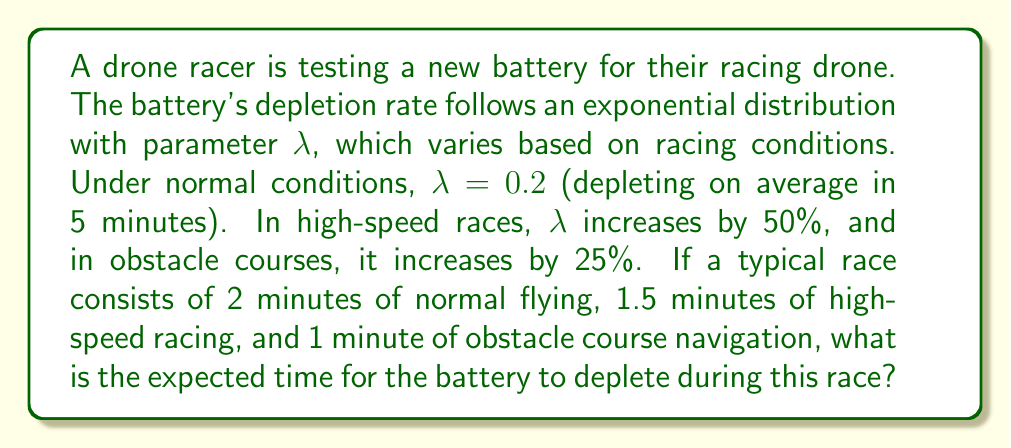Could you help me with this problem? Let's approach this step-by-step:

1) First, recall that for an exponential distribution with parameter $\lambda$, the expected value (mean time) is $\frac{1}{\lambda}$.

2) We have three different racing conditions:
   - Normal: $\lambda_1 = 0.2$
   - High-speed: $\lambda_2 = 0.2 \times 1.5 = 0.3$
   - Obstacle course: $\lambda_3 = 0.2 \times 1.25 = 0.25$

3) The race consists of different segments. We need to calculate the probability of the battery lasting through each segment and then multiply these probabilities.

4) For an exponential distribution, the probability of lasting time $t$ is $e^{-\lambda t}$. So for each segment:
   - Normal (2 min): $P_1 = e^{-0.2 \times 2} = e^{-0.4}$
   - High-speed (1.5 min): $P_2 = e^{-0.3 \times 1.5} = e^{-0.45}$
   - Obstacle (1 min): $P_3 = e^{-0.25 \times 1} = e^{-0.25}$

5) The probability of lasting through the entire race is:
   $P(total) = P_1 \times P_2 \times P_3 = e^{-0.4} \times e^{-0.45} \times e^{-0.25} = e^{-1.1}$

6) Now, we can calculate the expected time. The probability density function for the time of failure is:
   $f(t) = \lambda e^{-\lambda t}$, where $\lambda$ is the weighted average of the $\lambda$ values:
   $\lambda_{avg} = \frac{2 \times 0.2 + 1.5 \times 0.3 + 1 \times 0.25}{4.5} \approx 0.2444$

7) The expected time is thus:
   $E(T) = \int_0^{\infty} t \times 0.2444 e^{-0.2444t} dt = \frac{1}{0.2444} \approx 4.09$ minutes
Answer: 4.09 minutes 